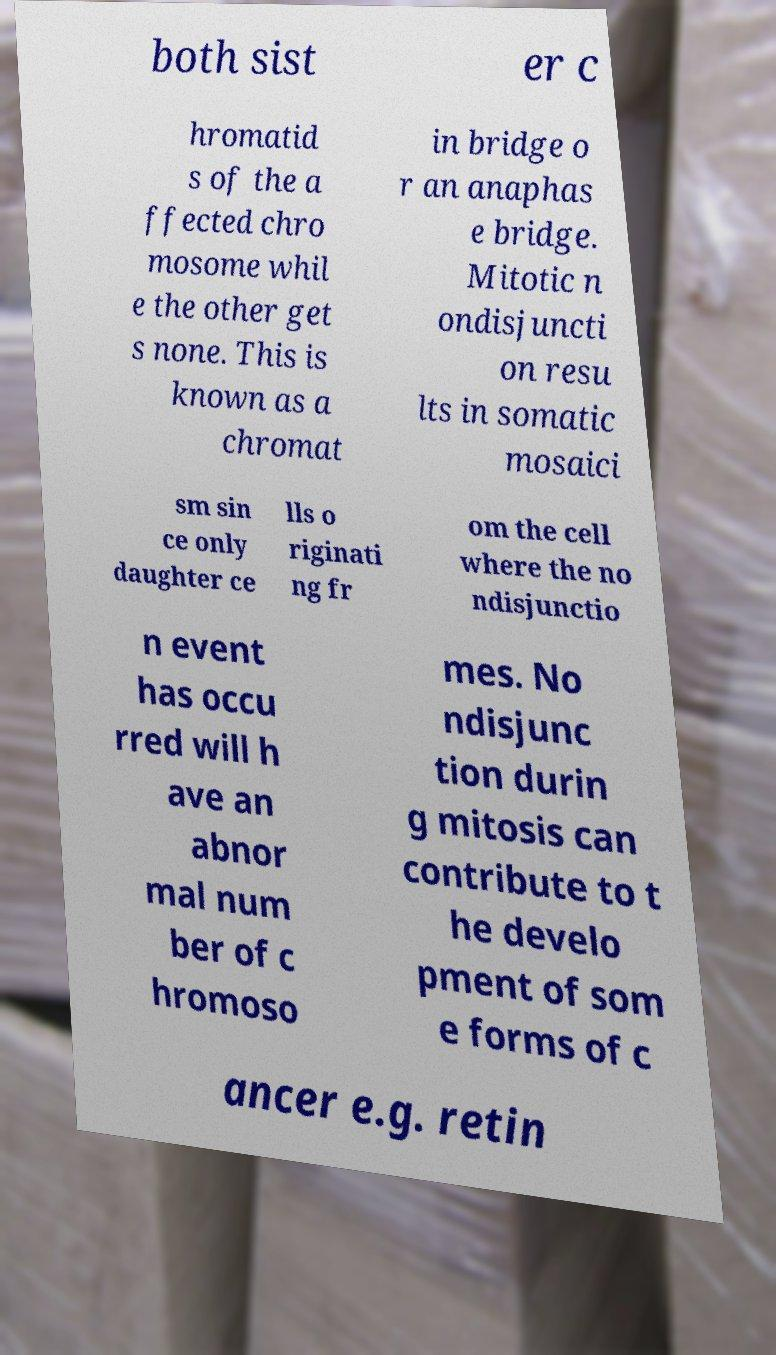Please read and relay the text visible in this image. What does it say? both sist er c hromatid s of the a ffected chro mosome whil e the other get s none. This is known as a chromat in bridge o r an anaphas e bridge. Mitotic n ondisjuncti on resu lts in somatic mosaici sm sin ce only daughter ce lls o riginati ng fr om the cell where the no ndisjunctio n event has occu rred will h ave an abnor mal num ber of c hromoso mes. No ndisjunc tion durin g mitosis can contribute to t he develo pment of som e forms of c ancer e.g. retin 